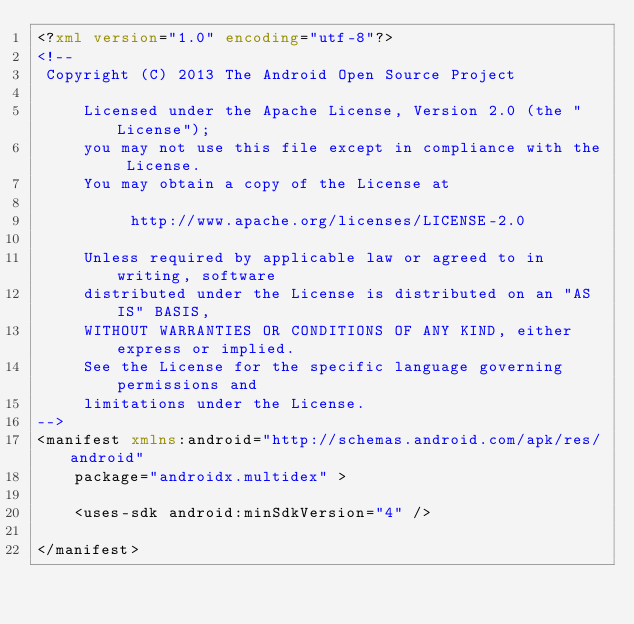Convert code to text. <code><loc_0><loc_0><loc_500><loc_500><_XML_><?xml version="1.0" encoding="utf-8"?>
<!--
 Copyright (C) 2013 The Android Open Source Project

     Licensed under the Apache License, Version 2.0 (the "License");
     you may not use this file except in compliance with the License.
     You may obtain a copy of the License at

          http://www.apache.org/licenses/LICENSE-2.0

     Unless required by applicable law or agreed to in writing, software
     distributed under the License is distributed on an "AS IS" BASIS,
     WITHOUT WARRANTIES OR CONDITIONS OF ANY KIND, either express or implied.
     See the License for the specific language governing permissions and
     limitations under the License.
-->
<manifest xmlns:android="http://schemas.android.com/apk/res/android"
    package="androidx.multidex" >

    <uses-sdk android:minSdkVersion="4" />

</manifest></code> 